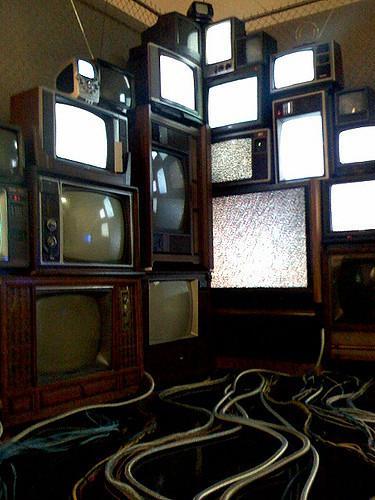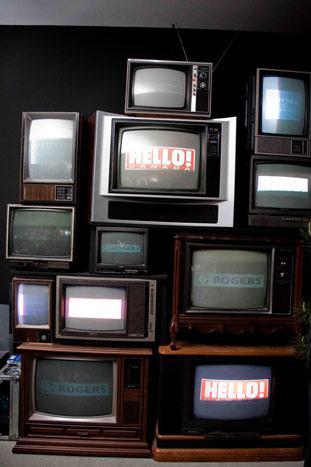The first image is the image on the left, the second image is the image on the right. For the images displayed, is the sentence "In one image, an arrangement of old televisions that are turned on to various channels is stacked at least three high, while a second image shows exactly five television or computer screens." factually correct? Answer yes or no. No. The first image is the image on the left, the second image is the image on the right. For the images shown, is this caption "There are exactly five televisions in the image on the left." true? Answer yes or no. No. 